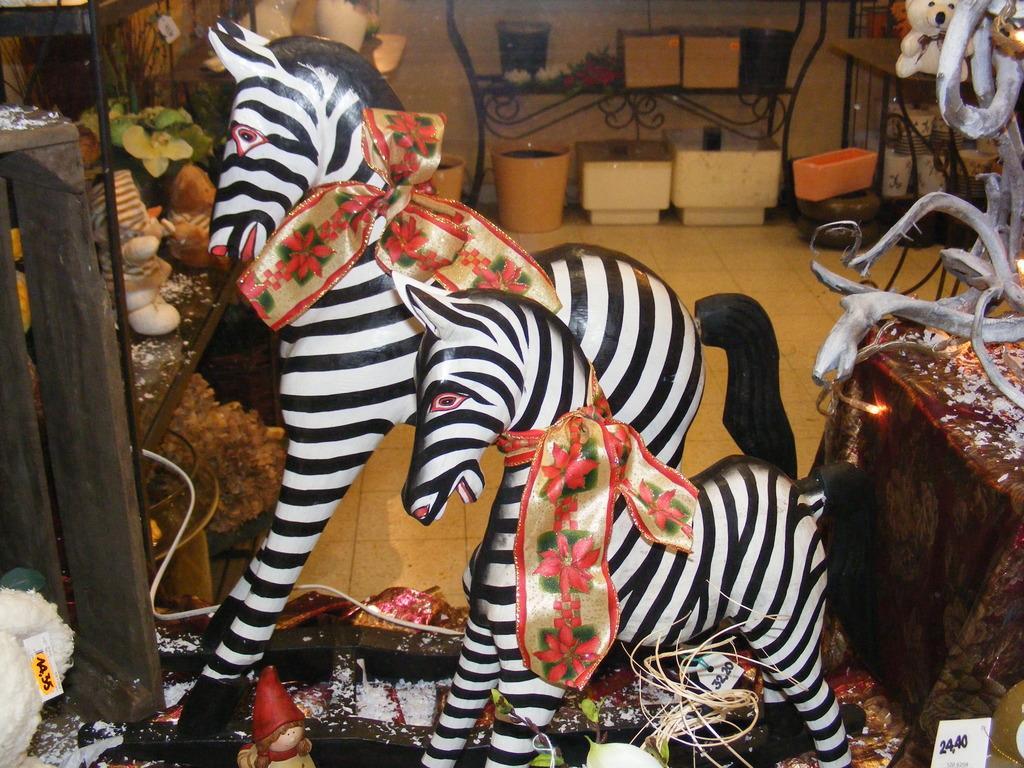Could you give a brief overview of what you see in this image? In this image I can see two toy zebras and some other objects are placed on the floor. On the right side there is a table which is covered with a cloth. On the left side there is a rack in which few toys are placed. In the background there are few pots, metal stands and some other objects are placed on the floor. 